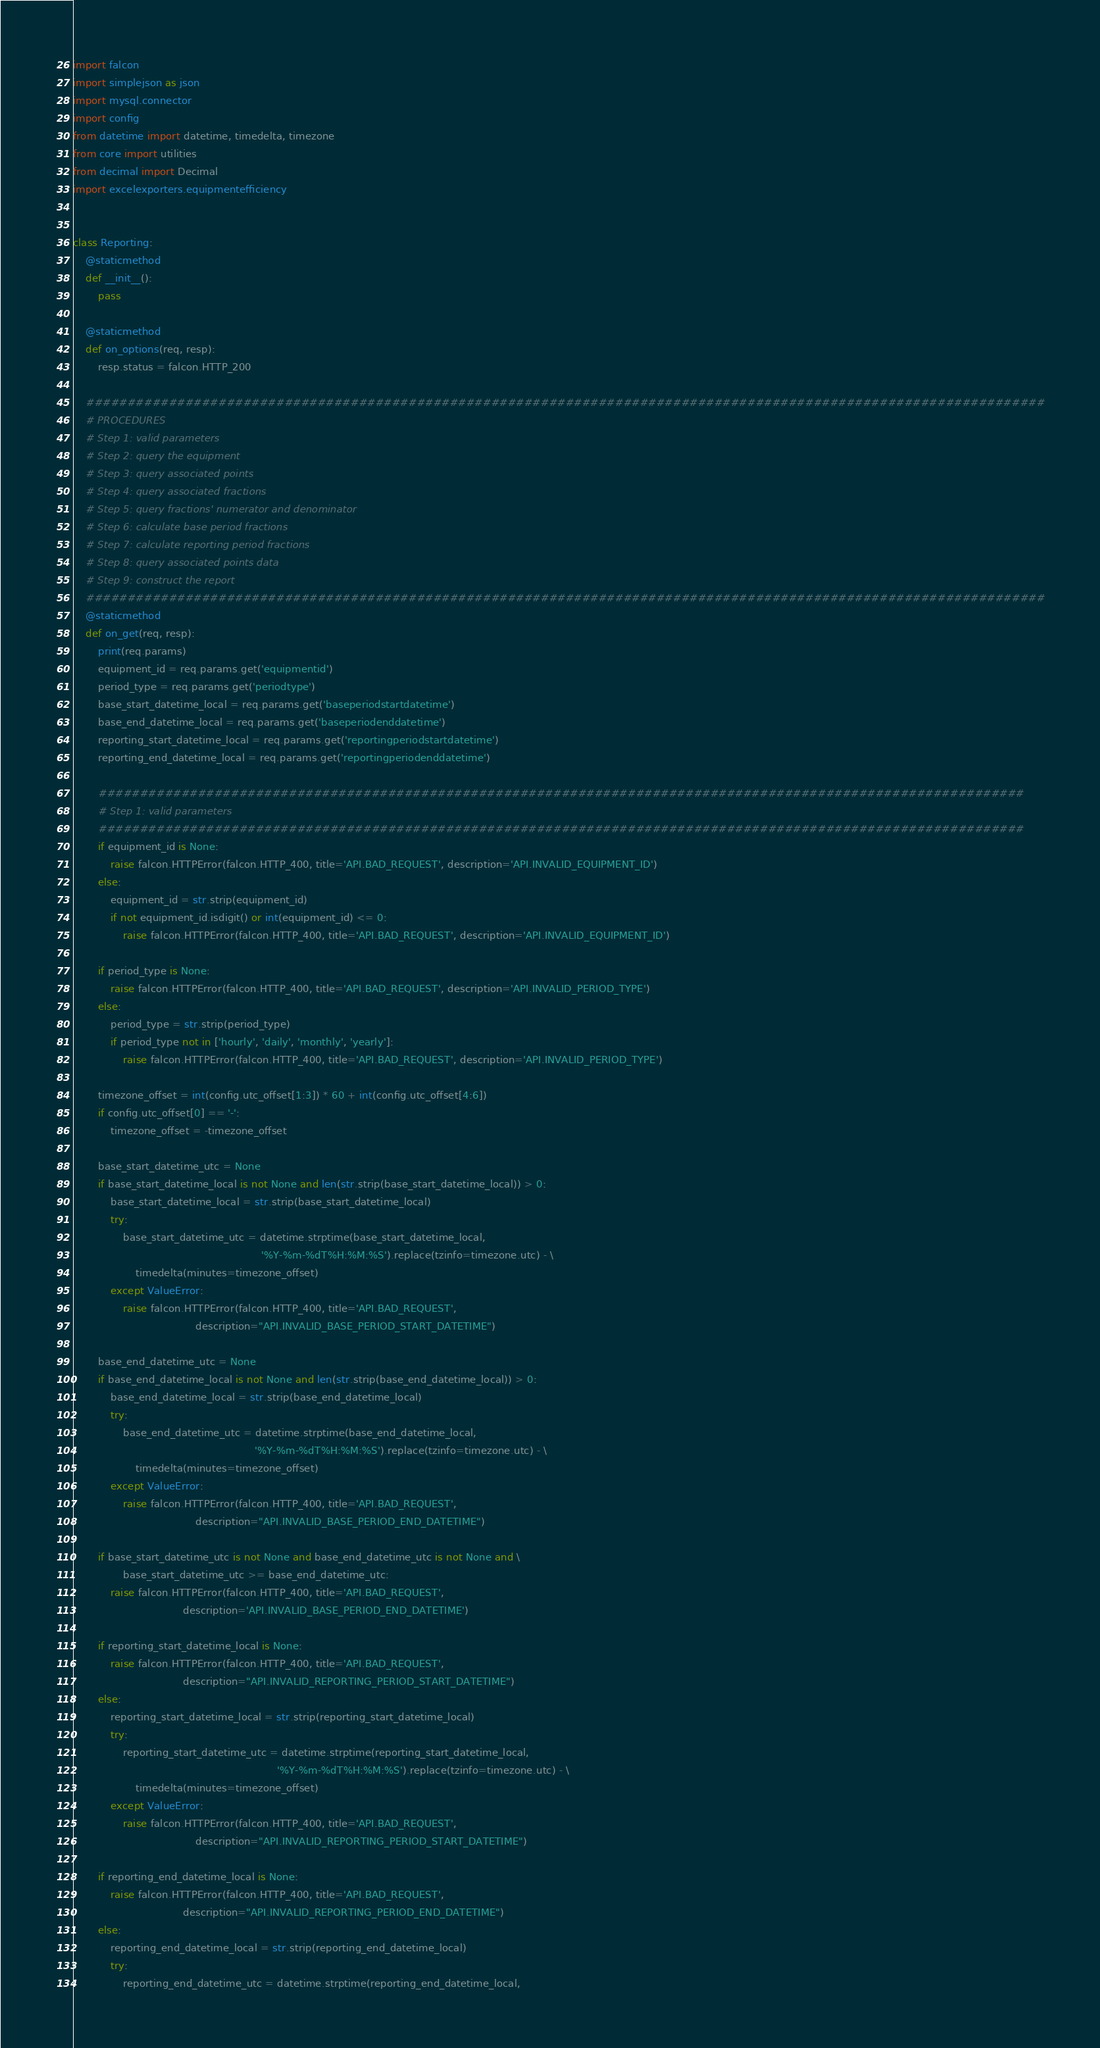Convert code to text. <code><loc_0><loc_0><loc_500><loc_500><_Python_>import falcon
import simplejson as json
import mysql.connector
import config
from datetime import datetime, timedelta, timezone
from core import utilities
from decimal import Decimal
import excelexporters.equipmentefficiency


class Reporting:
    @staticmethod
    def __init__():
        pass

    @staticmethod
    def on_options(req, resp):
        resp.status = falcon.HTTP_200

    ####################################################################################################################
    # PROCEDURES
    # Step 1: valid parameters
    # Step 2: query the equipment
    # Step 3: query associated points
    # Step 4: query associated fractions
    # Step 5: query fractions' numerator and denominator
    # Step 6: calculate base period fractions
    # Step 7: calculate reporting period fractions
    # Step 8: query associated points data
    # Step 9: construct the report
    ####################################################################################################################
    @staticmethod
    def on_get(req, resp):
        print(req.params)
        equipment_id = req.params.get('equipmentid')
        period_type = req.params.get('periodtype')
        base_start_datetime_local = req.params.get('baseperiodstartdatetime')
        base_end_datetime_local = req.params.get('baseperiodenddatetime')
        reporting_start_datetime_local = req.params.get('reportingperiodstartdatetime')
        reporting_end_datetime_local = req.params.get('reportingperiodenddatetime')

        ################################################################################################################
        # Step 1: valid parameters
        ################################################################################################################
        if equipment_id is None:
            raise falcon.HTTPError(falcon.HTTP_400, title='API.BAD_REQUEST', description='API.INVALID_EQUIPMENT_ID')
        else:
            equipment_id = str.strip(equipment_id)
            if not equipment_id.isdigit() or int(equipment_id) <= 0:
                raise falcon.HTTPError(falcon.HTTP_400, title='API.BAD_REQUEST', description='API.INVALID_EQUIPMENT_ID')

        if period_type is None:
            raise falcon.HTTPError(falcon.HTTP_400, title='API.BAD_REQUEST', description='API.INVALID_PERIOD_TYPE')
        else:
            period_type = str.strip(period_type)
            if period_type not in ['hourly', 'daily', 'monthly', 'yearly']:
                raise falcon.HTTPError(falcon.HTTP_400, title='API.BAD_REQUEST', description='API.INVALID_PERIOD_TYPE')

        timezone_offset = int(config.utc_offset[1:3]) * 60 + int(config.utc_offset[4:6])
        if config.utc_offset[0] == '-':
            timezone_offset = -timezone_offset

        base_start_datetime_utc = None
        if base_start_datetime_local is not None and len(str.strip(base_start_datetime_local)) > 0:
            base_start_datetime_local = str.strip(base_start_datetime_local)
            try:
                base_start_datetime_utc = datetime.strptime(base_start_datetime_local,
                                                            '%Y-%m-%dT%H:%M:%S').replace(tzinfo=timezone.utc) - \
                    timedelta(minutes=timezone_offset)
            except ValueError:
                raise falcon.HTTPError(falcon.HTTP_400, title='API.BAD_REQUEST',
                                       description="API.INVALID_BASE_PERIOD_START_DATETIME")

        base_end_datetime_utc = None
        if base_end_datetime_local is not None and len(str.strip(base_end_datetime_local)) > 0:
            base_end_datetime_local = str.strip(base_end_datetime_local)
            try:
                base_end_datetime_utc = datetime.strptime(base_end_datetime_local,
                                                          '%Y-%m-%dT%H:%M:%S').replace(tzinfo=timezone.utc) - \
                    timedelta(minutes=timezone_offset)
            except ValueError:
                raise falcon.HTTPError(falcon.HTTP_400, title='API.BAD_REQUEST',
                                       description="API.INVALID_BASE_PERIOD_END_DATETIME")

        if base_start_datetime_utc is not None and base_end_datetime_utc is not None and \
                base_start_datetime_utc >= base_end_datetime_utc:
            raise falcon.HTTPError(falcon.HTTP_400, title='API.BAD_REQUEST',
                                   description='API.INVALID_BASE_PERIOD_END_DATETIME')

        if reporting_start_datetime_local is None:
            raise falcon.HTTPError(falcon.HTTP_400, title='API.BAD_REQUEST',
                                   description="API.INVALID_REPORTING_PERIOD_START_DATETIME")
        else:
            reporting_start_datetime_local = str.strip(reporting_start_datetime_local)
            try:
                reporting_start_datetime_utc = datetime.strptime(reporting_start_datetime_local,
                                                                 '%Y-%m-%dT%H:%M:%S').replace(tzinfo=timezone.utc) - \
                    timedelta(minutes=timezone_offset)
            except ValueError:
                raise falcon.HTTPError(falcon.HTTP_400, title='API.BAD_REQUEST',
                                       description="API.INVALID_REPORTING_PERIOD_START_DATETIME")

        if reporting_end_datetime_local is None:
            raise falcon.HTTPError(falcon.HTTP_400, title='API.BAD_REQUEST',
                                   description="API.INVALID_REPORTING_PERIOD_END_DATETIME")
        else:
            reporting_end_datetime_local = str.strip(reporting_end_datetime_local)
            try:
                reporting_end_datetime_utc = datetime.strptime(reporting_end_datetime_local,</code> 